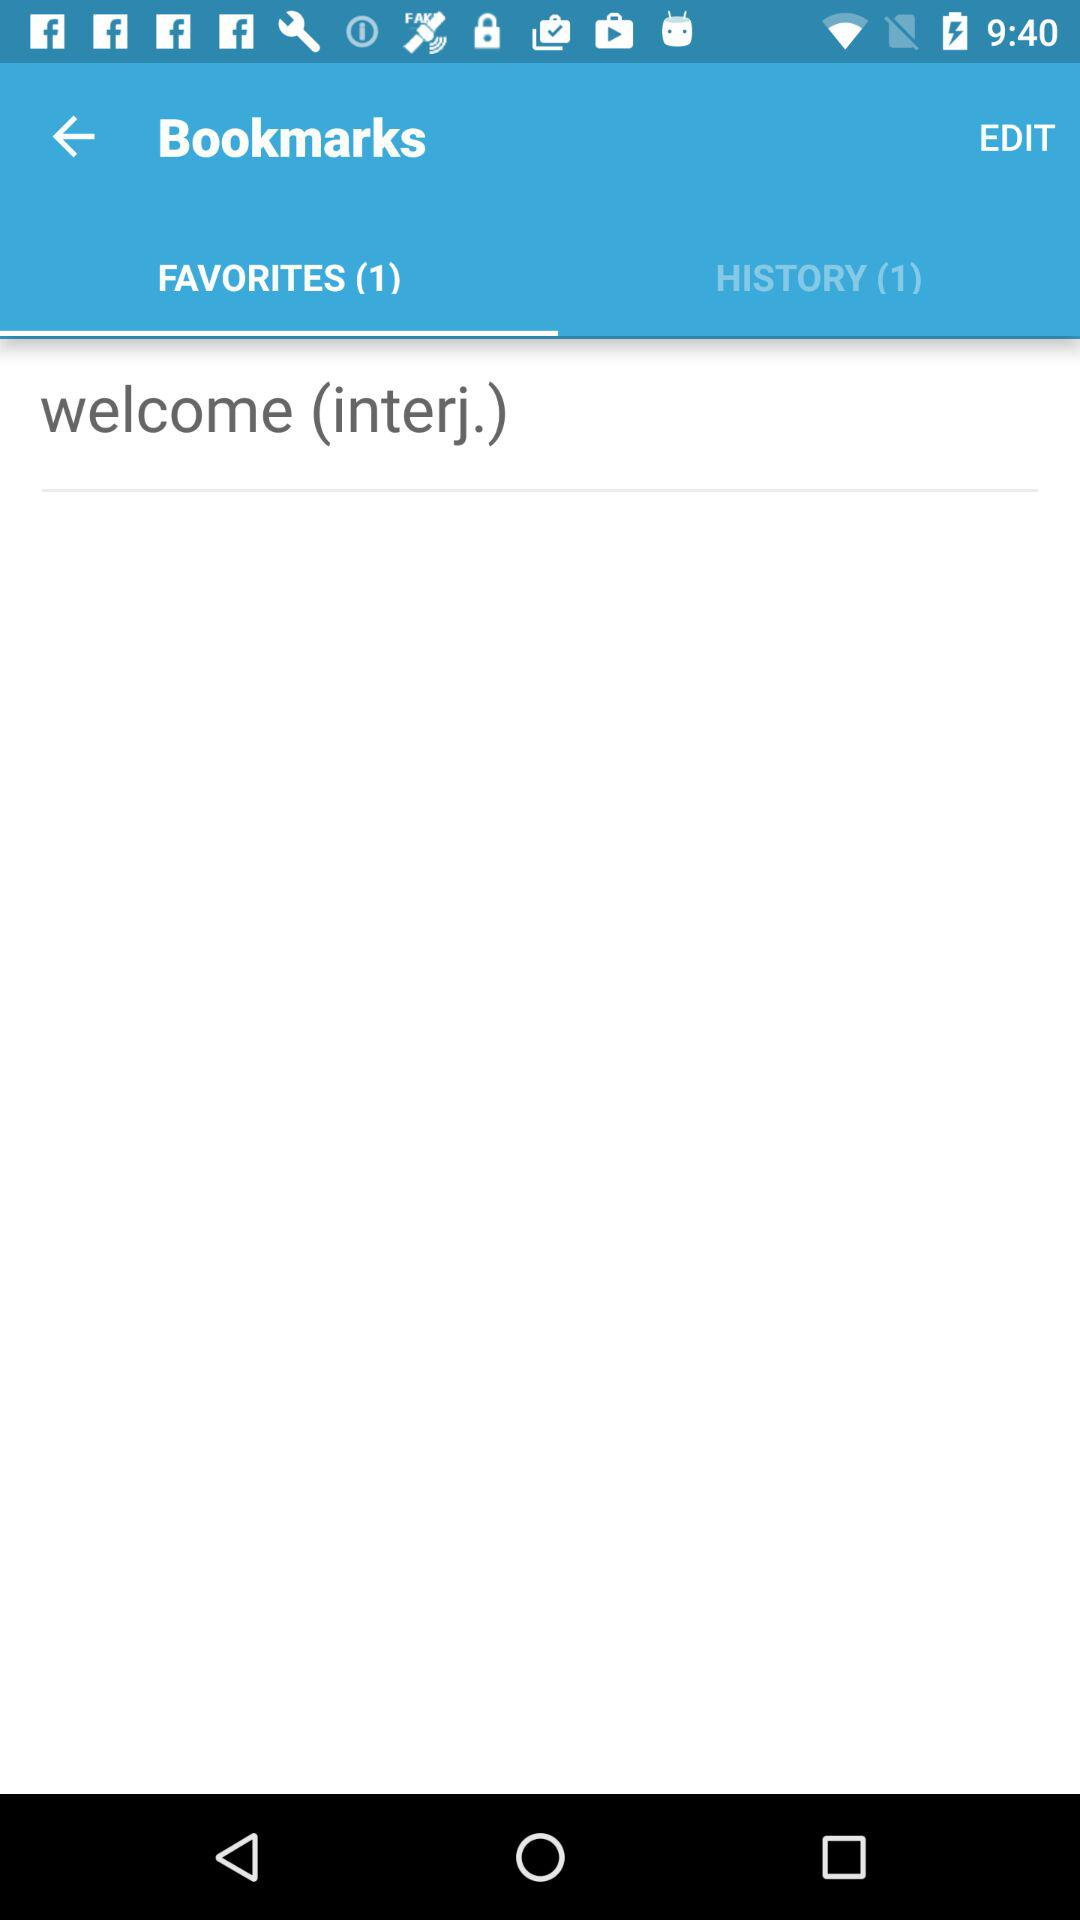What is the available bookmark in favorites? The available bookmark in favorites is "welcome (interj.)". 